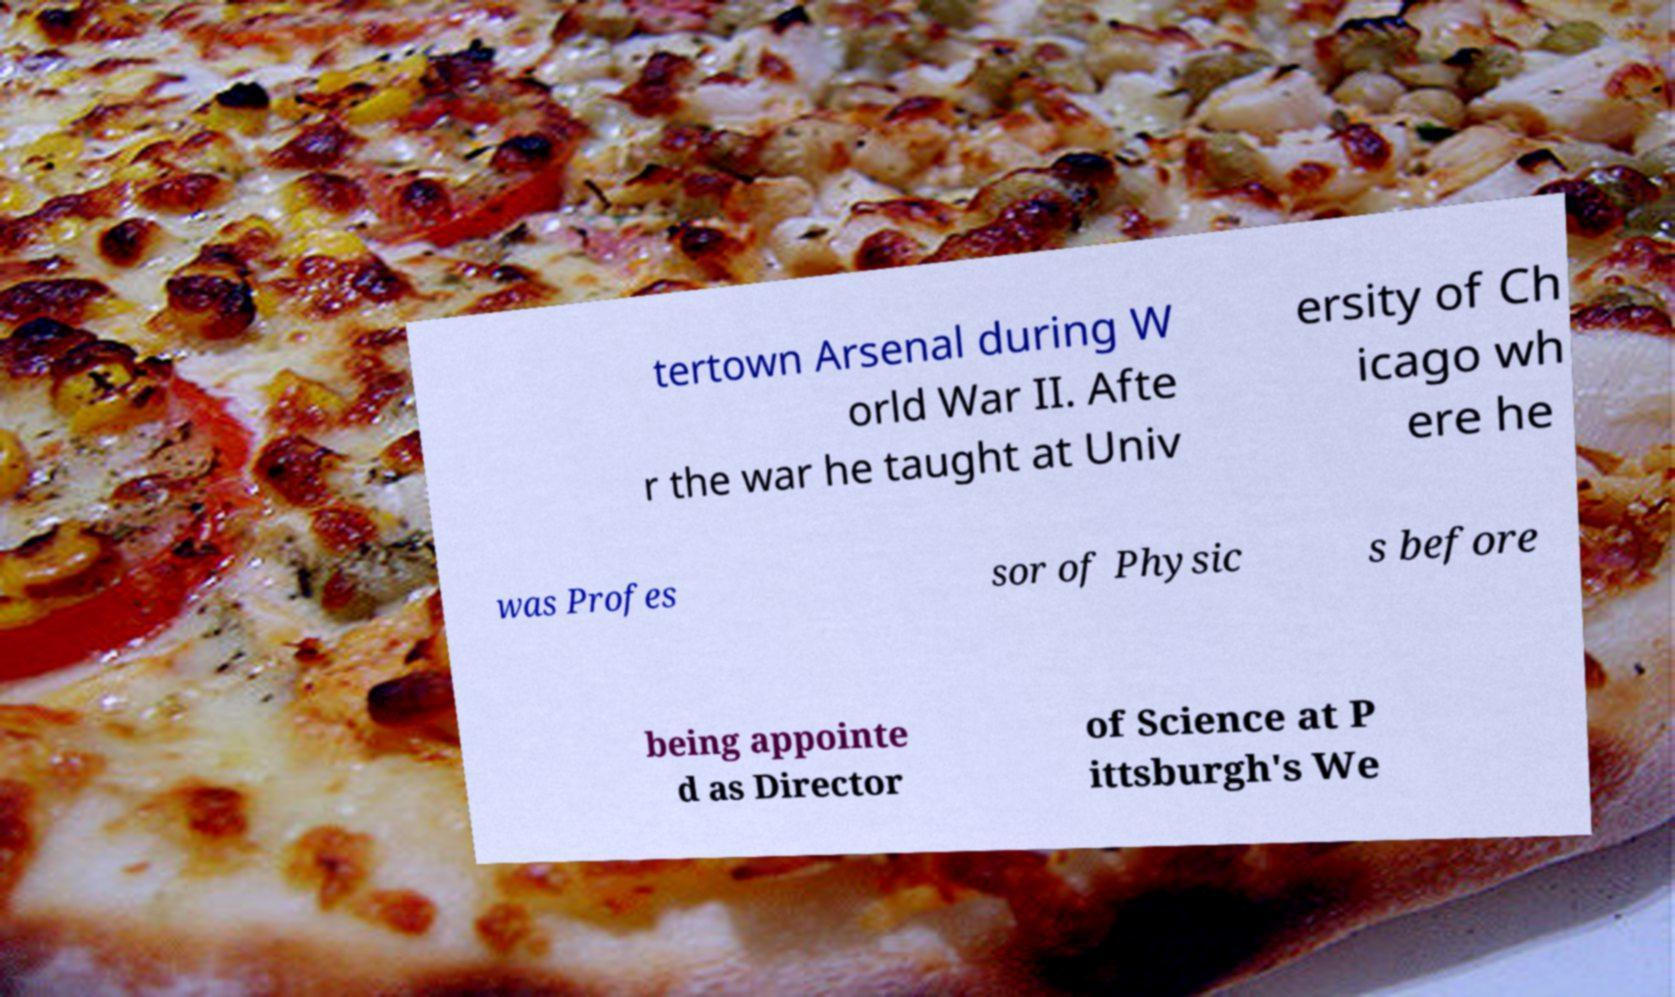I need the written content from this picture converted into text. Can you do that? tertown Arsenal during W orld War II. Afte r the war he taught at Univ ersity of Ch icago wh ere he was Profes sor of Physic s before being appointe d as Director of Science at P ittsburgh's We 